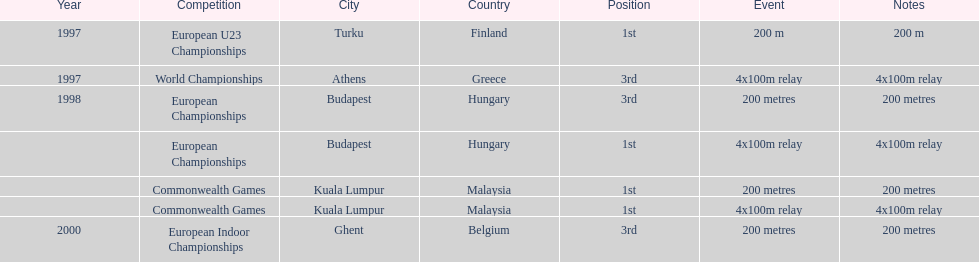How many competitions were in budapest, hungary and came in 1st position? 1. 